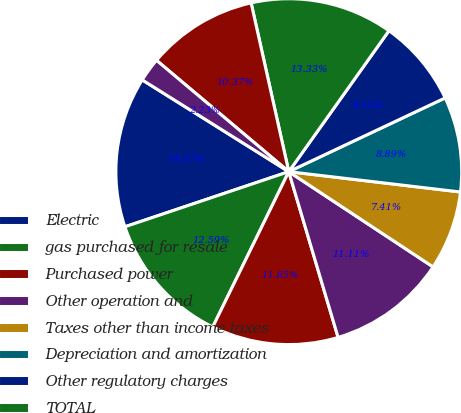<chart> <loc_0><loc_0><loc_500><loc_500><pie_chart><fcel>Electric<fcel>gas purchased for resale<fcel>Purchased power<fcel>Other operation and<fcel>Taxes other than income taxes<fcel>Depreciation and amortization<fcel>Other regulatory charges<fcel>TOTAL<fcel>OPERATING INCOME<fcel>Allowance for equity funds<nl><fcel>14.07%<fcel>12.59%<fcel>11.85%<fcel>11.11%<fcel>7.41%<fcel>8.89%<fcel>8.15%<fcel>13.33%<fcel>10.37%<fcel>2.23%<nl></chart> 